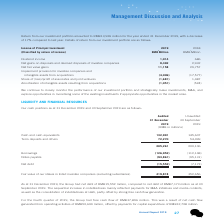According to Tencent's financial document, What is the group's net debt as at 31 December 2019? According to the financial document, RMB15,552 million. The relevant text states: "As at 31 December 2019, the Group had net debt of RMB15,552 million, compared to net debt of RMB7,173 million as at 30..." Also, What is the group's net debt as at 30 September 2019? According to the financial document, RMB7,173 million. The relevant text states: "ebt of RMB15,552 million, compared to net debt of RMB7,173 million as at 30..." Also, What was the group's cash flow for the fourth quarter of 2019? According to the financial document, RMB37,896 million. The relevant text states: "quarter of 2019, the Group had free cash flow of RMB37,896 million. This was a result of net cash flow..." Also, can you calculate: What is the difference between cash and cash equivalents of 30 September and 31 December 2019? Based on the calculation: 145,607-132,991, the result is 12616 (in millions). This is based on the information: "Cash and cash equivalents 132,991 145,607 Cash and cash equivalents 132,991 145,607..." The key data points involved are: 132,991, 145,607. Also, can you calculate: What is the change in borrowings between 31 December 2019 and 30 September 2019? Based on the calculation: 126,952-112,148, the result is 14804 (in millions). This is based on the information: "Borrowings (126,952) (112,148) Borrowings (126,952) (112,148)..." The key data points involved are: 112,148, 126,952. Also, can you calculate: What is the change in notes payable between 31 December 2019 and 30 September 2019? Based on the calculation: 95,131-93,861, the result is 1270 (in millions). This is based on the information: "Notes payable (93,861) (95,131) Notes payable (93,861) (95,131)..." The key data points involved are: 93,861, 95,131. 